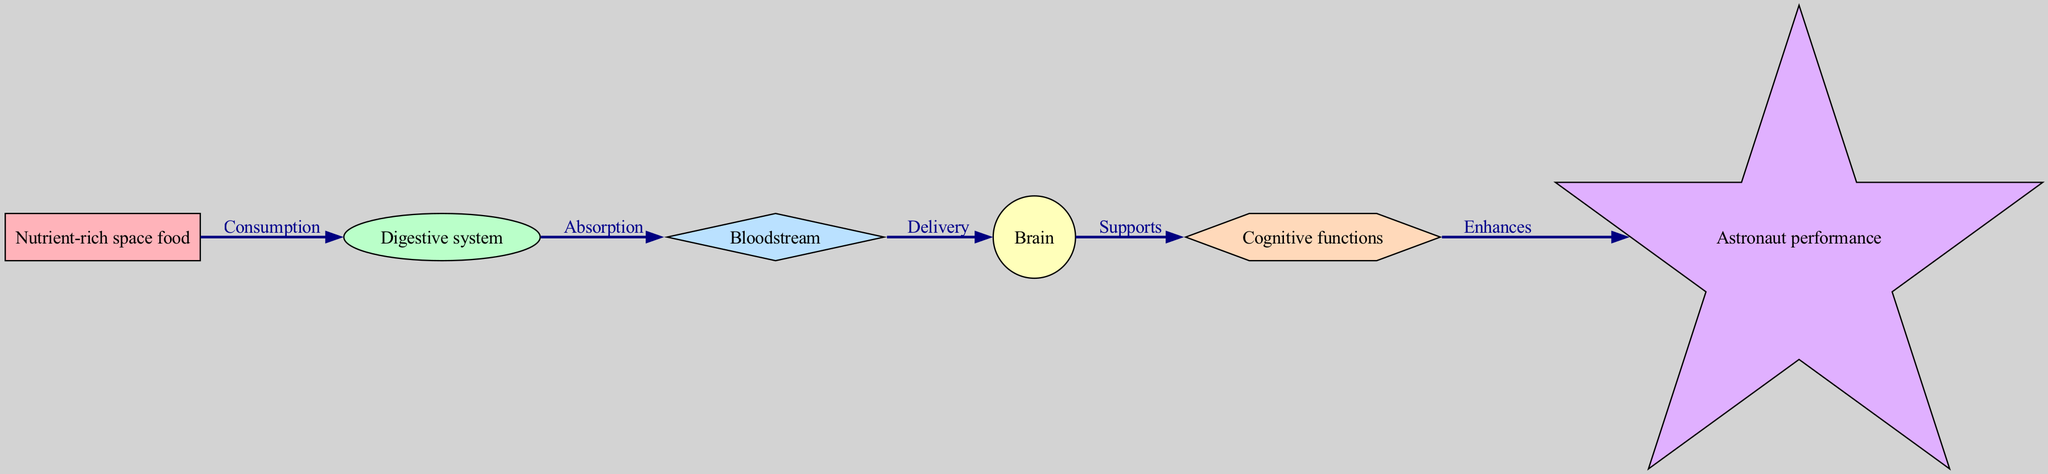What is the first node in the diagram? The first node in the diagram is "Nutrient-rich space food," as it is the starting point of the food chain depicting the flow of nutrients.
Answer: Nutrient-rich space food How many nodes are in the diagram? The diagram contains six nodes, which are the distinct stages from nutrients to astronaut performance.
Answer: 6 What is the label on the edge from the Digestive system to the Bloodstream? The label on the edge connecting the Digestive system to the Bloodstream is "Absorption," indicating the process through which nutrients move into the bloodstream.
Answer: Absorption Which node supports cognitive functions? The node that supports cognitive functions is the "Brain," as indicated by the flow direction from the Brain to the Cognitive functions node in the diagram.
Answer: Brain If all cognitive functions are enhanced, what is the impact on astronaut performance? The enhancement of cognitive functions directly improves astronaut performance according to the flow of the diagram, where enhancement leads to better performance outcomes.
Answer: Enhances What type of relationship is depicted between the Bloodstream and the Brain? The relationship between the Bloodstream and the Brain is labeled "Delivery," indicating the transport of nutrients to the brain for functioning.
Answer: Delivery What comes after Cognitive functions in the food chain? After Cognitive functions in the food chain, the next node is "Astronaut performance," showing the last step where cognitive enhancement translates to performance.
Answer: Astronaut performance Which node sends nutrients to the Bloodstream? The node that sends nutrients to the Bloodstream is the "Digestive system," which absorbs nutrients from food and delivers them to the bloodstream.
Answer: Digestive system What is the significance of nutrient-rich space food in the diagram? Nutrient-rich space food is significant as it is the starting point of the food chain, serving as the source of nutrients that begin the process leading to astronaut performance.
Answer: Starting point 